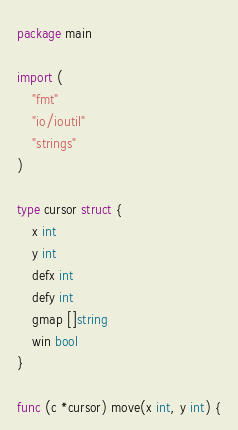<code> <loc_0><loc_0><loc_500><loc_500><_Go_>package main

import (
	"fmt"
	"io/ioutil"
	"strings"
)

type cursor struct {
	x int
	y int
	defx int
	defy int
	gmap []string
	win bool
}

func (c *cursor) move(x int, y int) {
</code> 